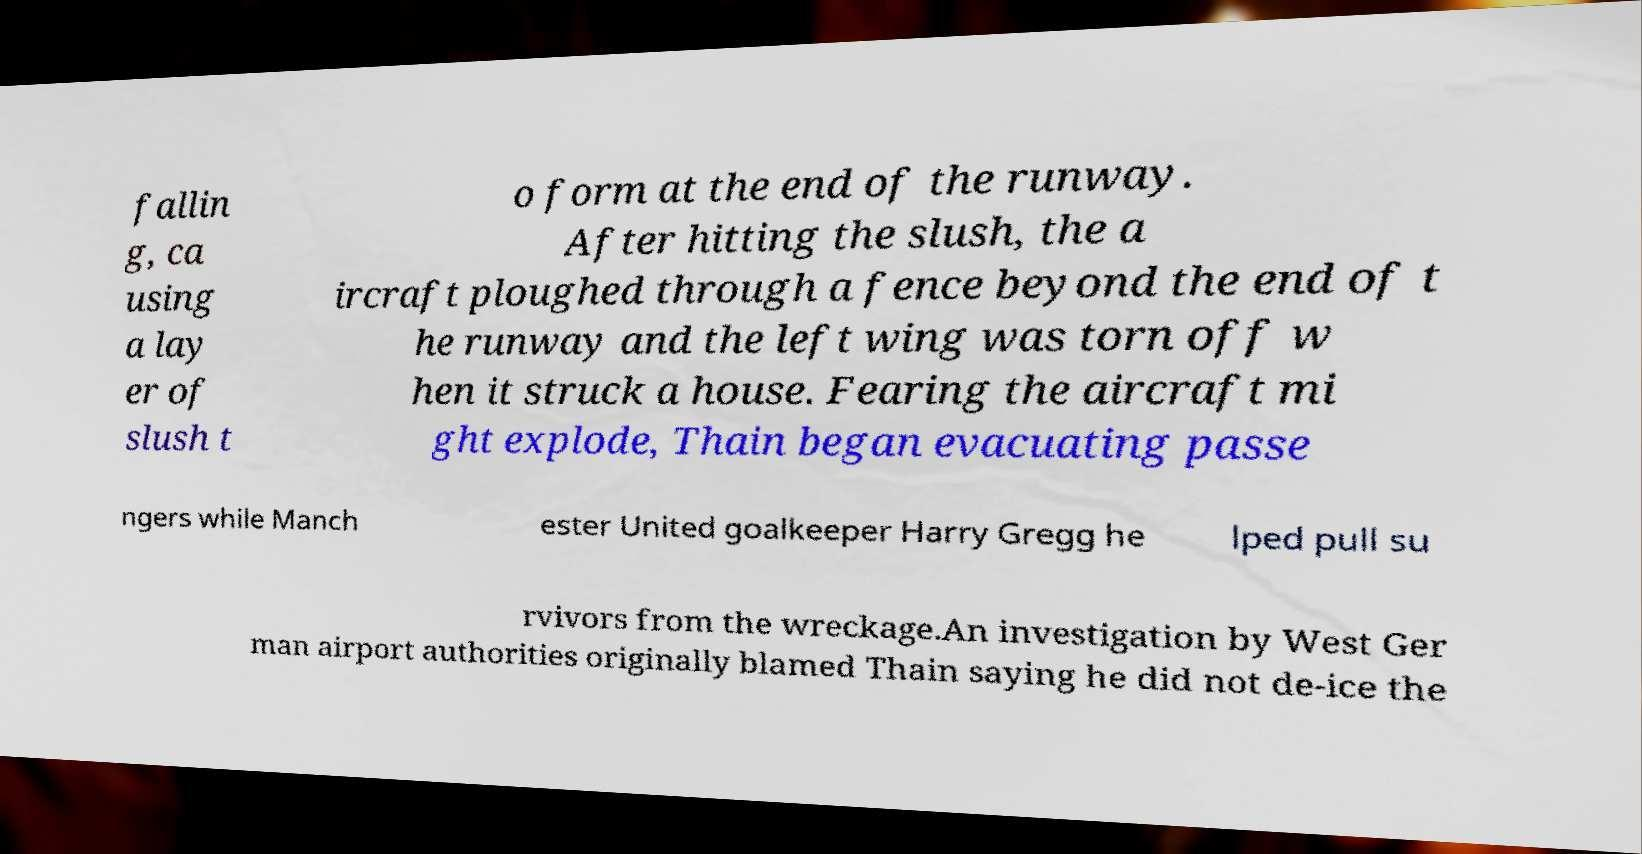Can you accurately transcribe the text from the provided image for me? fallin g, ca using a lay er of slush t o form at the end of the runway. After hitting the slush, the a ircraft ploughed through a fence beyond the end of t he runway and the left wing was torn off w hen it struck a house. Fearing the aircraft mi ght explode, Thain began evacuating passe ngers while Manch ester United goalkeeper Harry Gregg he lped pull su rvivors from the wreckage.An investigation by West Ger man airport authorities originally blamed Thain saying he did not de-ice the 